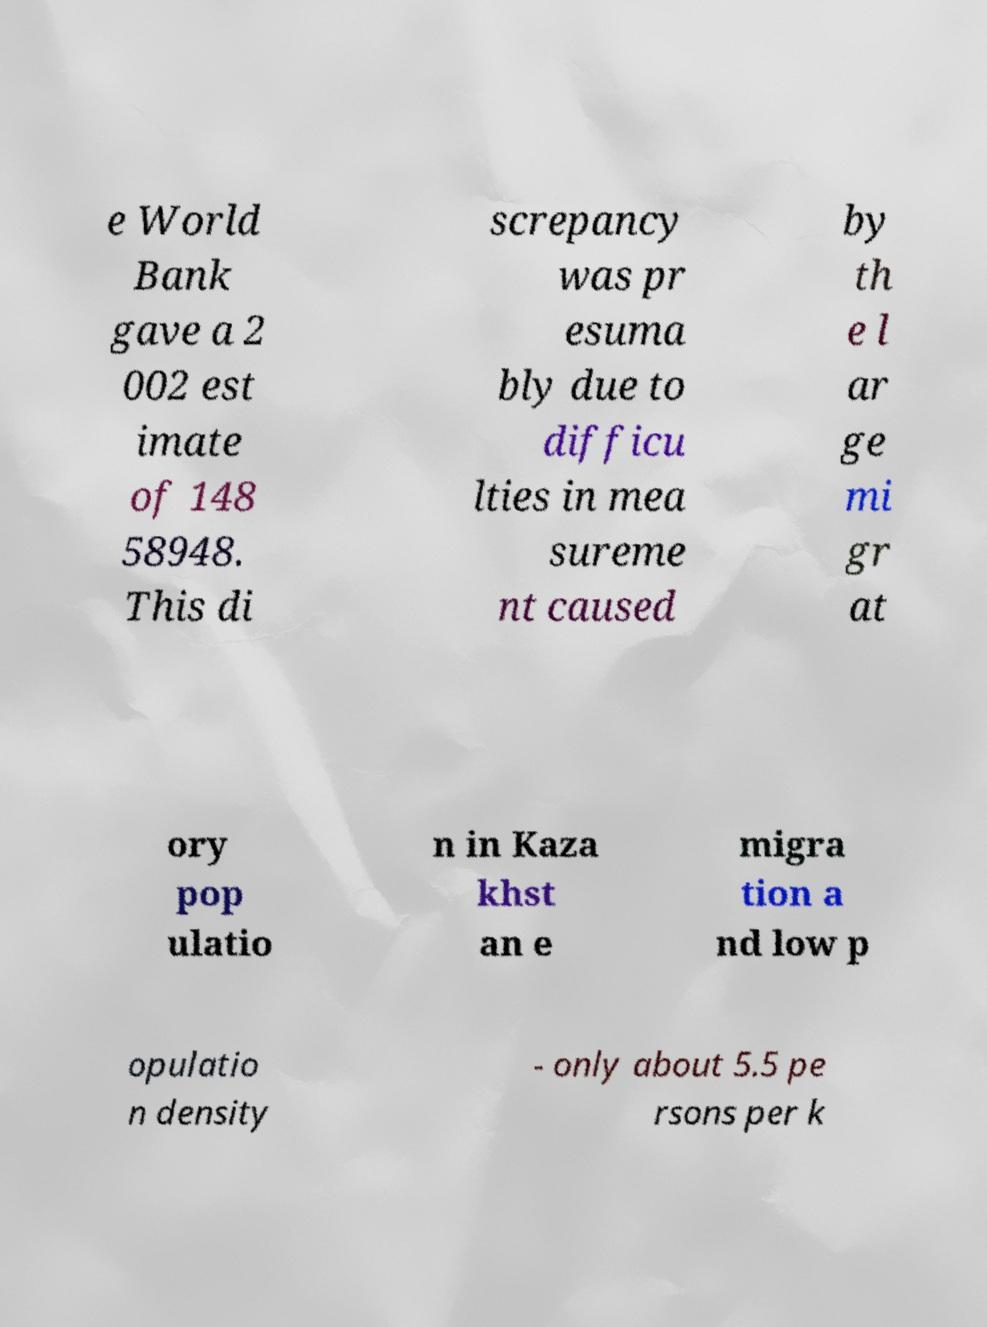Can you read and provide the text displayed in the image?This photo seems to have some interesting text. Can you extract and type it out for me? e World Bank gave a 2 002 est imate of 148 58948. This di screpancy was pr esuma bly due to difficu lties in mea sureme nt caused by th e l ar ge mi gr at ory pop ulatio n in Kaza khst an e migra tion a nd low p opulatio n density - only about 5.5 pe rsons per k 